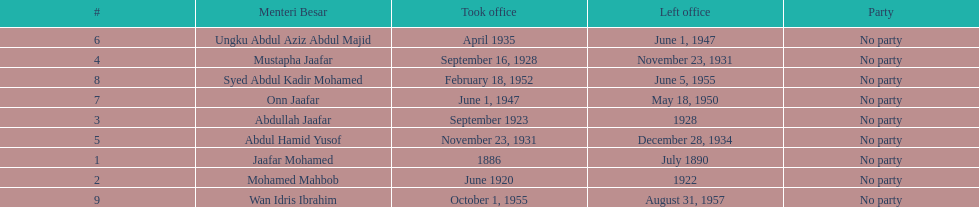Who was in office after mustapha jaafar Abdul Hamid Yusof. 